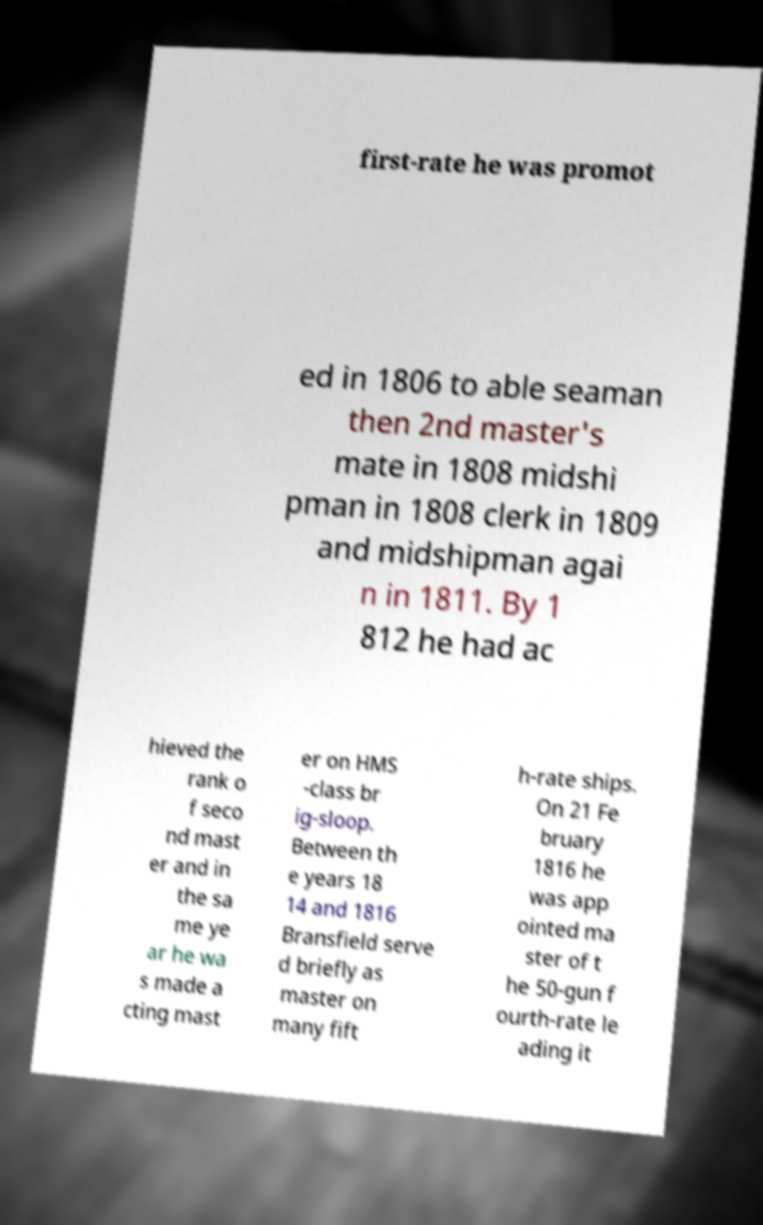Can you accurately transcribe the text from the provided image for me? first-rate he was promot ed in 1806 to able seaman then 2nd master's mate in 1808 midshi pman in 1808 clerk in 1809 and midshipman agai n in 1811. By 1 812 he had ac hieved the rank o f seco nd mast er and in the sa me ye ar he wa s made a cting mast er on HMS -class br ig-sloop. Between th e years 18 14 and 1816 Bransfield serve d briefly as master on many fift h-rate ships. On 21 Fe bruary 1816 he was app ointed ma ster of t he 50-gun f ourth-rate le ading it 